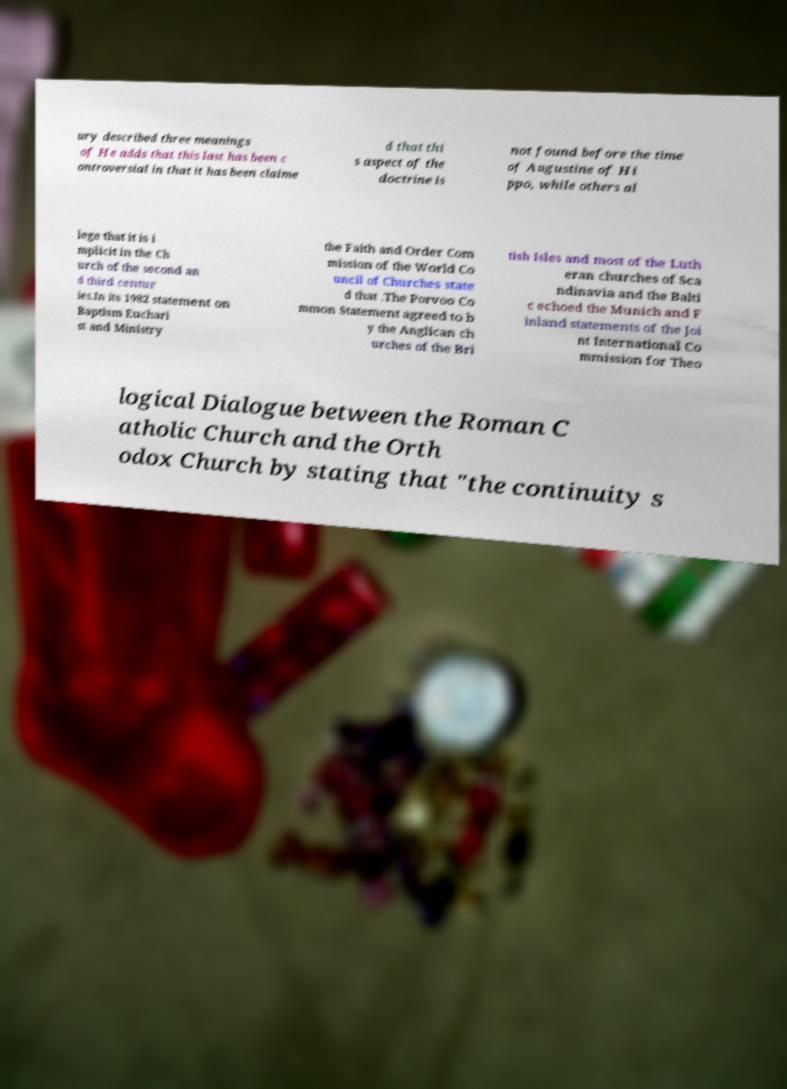Can you accurately transcribe the text from the provided image for me? ury described three meanings of He adds that this last has been c ontroversial in that it has been claime d that thi s aspect of the doctrine is not found before the time of Augustine of Hi ppo, while others al lege that it is i mplicit in the Ch urch of the second an d third centur ies.In its 1982 statement on Baptism Euchari st and Ministry the Faith and Order Com mission of the World Co uncil of Churches state d that .The Porvoo Co mmon Statement agreed to b y the Anglican ch urches of the Bri tish Isles and most of the Luth eran churches of Sca ndinavia and the Balti c echoed the Munich and F inland statements of the Joi nt International Co mmission for Theo logical Dialogue between the Roman C atholic Church and the Orth odox Church by stating that "the continuity s 